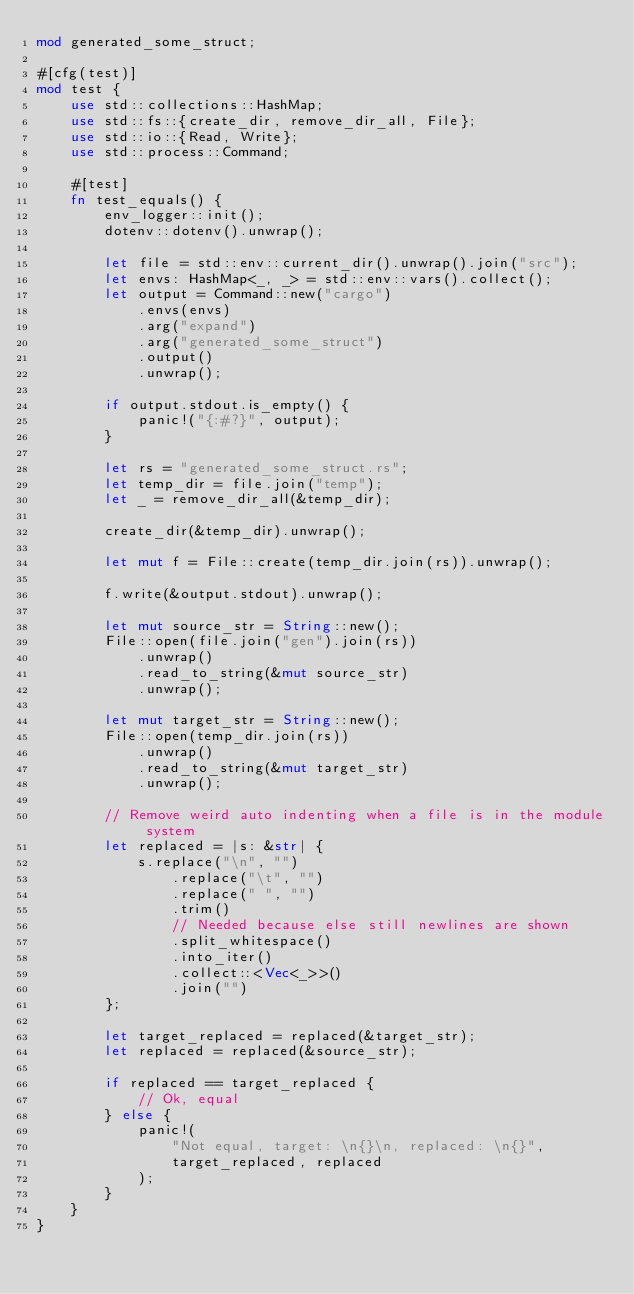<code> <loc_0><loc_0><loc_500><loc_500><_Rust_>mod generated_some_struct;

#[cfg(test)]
mod test {
    use std::collections::HashMap;
    use std::fs::{create_dir, remove_dir_all, File};
    use std::io::{Read, Write};
    use std::process::Command;

    #[test]
    fn test_equals() {
        env_logger::init();
        dotenv::dotenv().unwrap();

        let file = std::env::current_dir().unwrap().join("src");
        let envs: HashMap<_, _> = std::env::vars().collect();
        let output = Command::new("cargo")
            .envs(envs)
            .arg("expand")
            .arg("generated_some_struct")
            .output()
            .unwrap();

        if output.stdout.is_empty() {
            panic!("{:#?}", output);
        }

        let rs = "generated_some_struct.rs";
        let temp_dir = file.join("temp");
        let _ = remove_dir_all(&temp_dir);

        create_dir(&temp_dir).unwrap();

        let mut f = File::create(temp_dir.join(rs)).unwrap();

        f.write(&output.stdout).unwrap();

        let mut source_str = String::new();
        File::open(file.join("gen").join(rs))
            .unwrap()
            .read_to_string(&mut source_str)
            .unwrap();

        let mut target_str = String::new();
        File::open(temp_dir.join(rs))
            .unwrap()
            .read_to_string(&mut target_str)
            .unwrap();

        // Remove weird auto indenting when a file is in the module system
        let replaced = |s: &str| {
            s.replace("\n", "")
                .replace("\t", "")
                .replace(" ", "")
                .trim()
                // Needed because else still newlines are shown
                .split_whitespace()
                .into_iter()
                .collect::<Vec<_>>()
                .join("")
        };

        let target_replaced = replaced(&target_str);
        let replaced = replaced(&source_str);

        if replaced == target_replaced {
            // Ok, equal
        } else {
            panic!(
                "Not equal, target: \n{}\n, replaced: \n{}",
                target_replaced, replaced
            );
        }
    }
}
</code> 